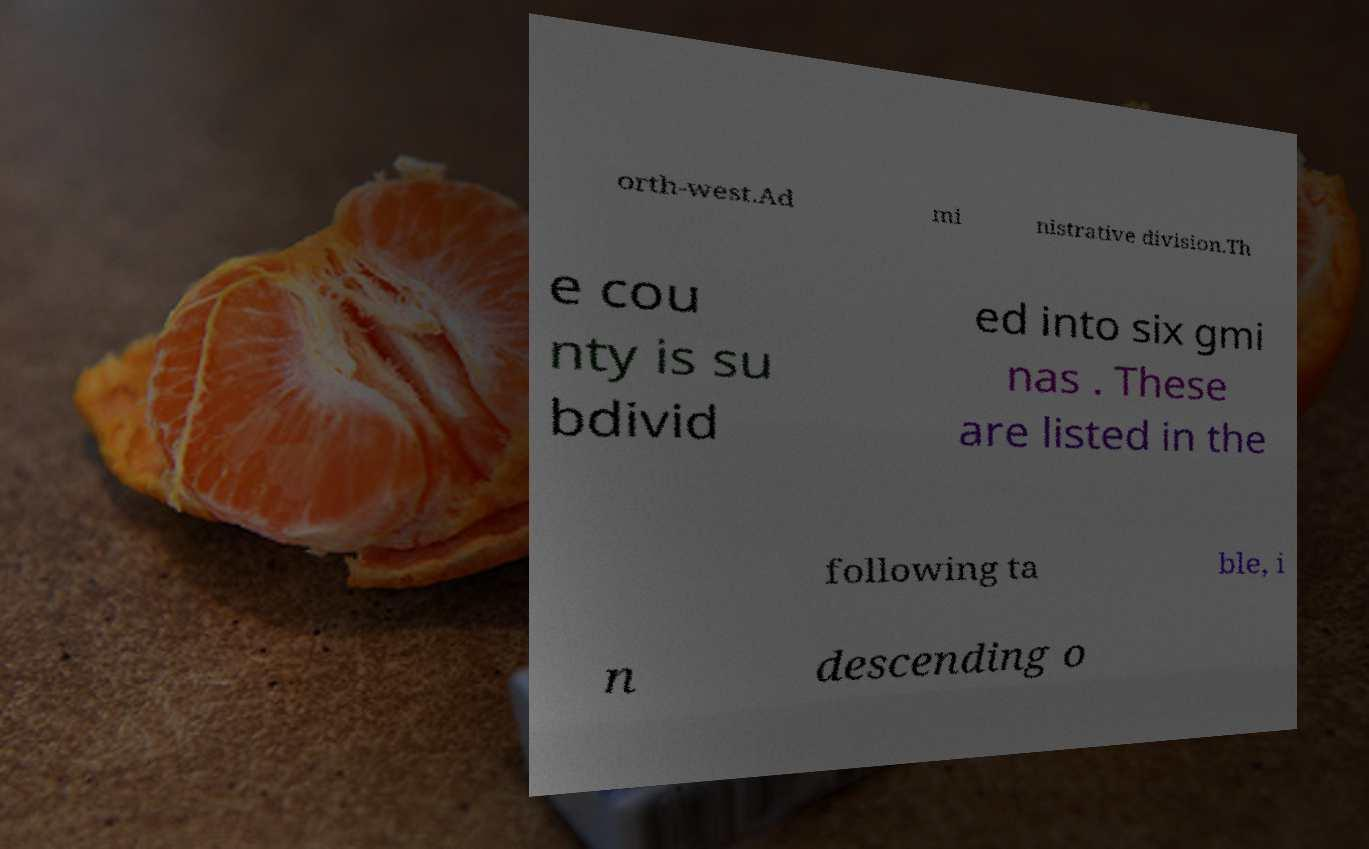Can you read and provide the text displayed in the image?This photo seems to have some interesting text. Can you extract and type it out for me? orth-west.Ad mi nistrative division.Th e cou nty is su bdivid ed into six gmi nas . These are listed in the following ta ble, i n descending o 